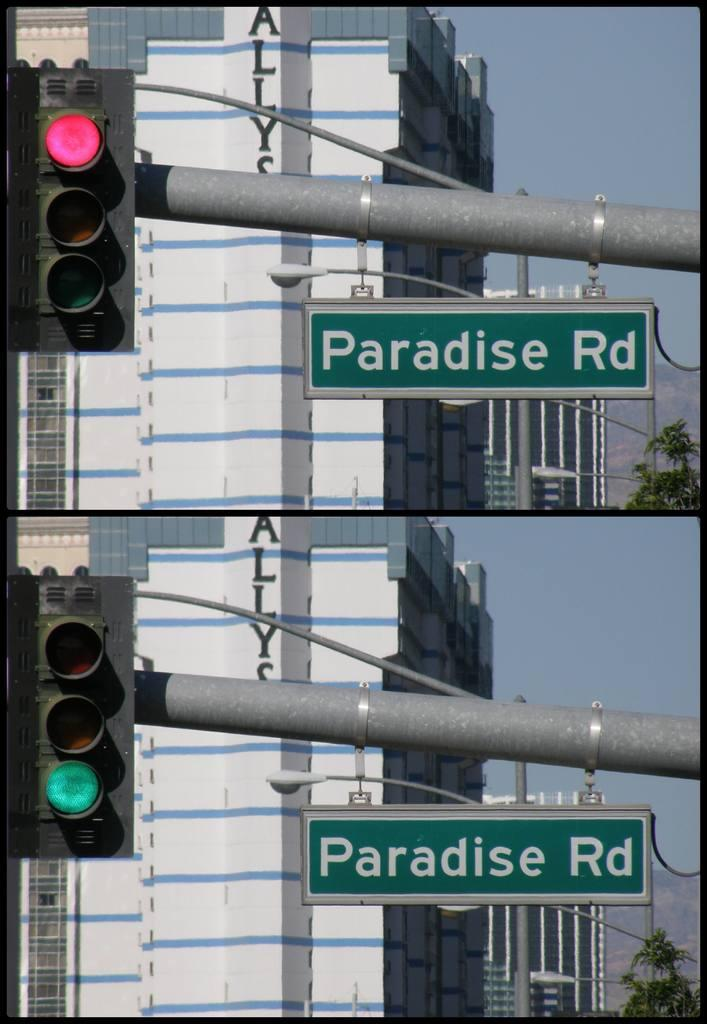<image>
Give a short and clear explanation of the subsequent image. The stoplight is red and then turns to green on Paradise Rd. 